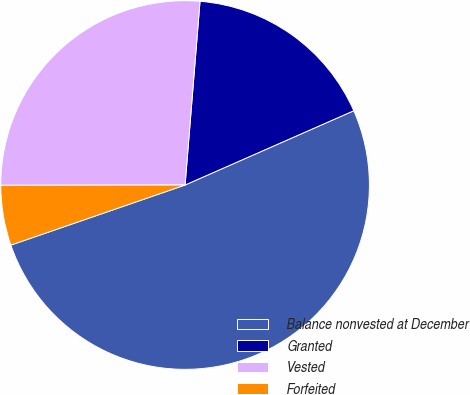<chart> <loc_0><loc_0><loc_500><loc_500><pie_chart><fcel>Balance nonvested at December<fcel>Granted<fcel>Vested<fcel>Forfeited<nl><fcel>51.32%<fcel>17.11%<fcel>26.32%<fcel>5.26%<nl></chart> 